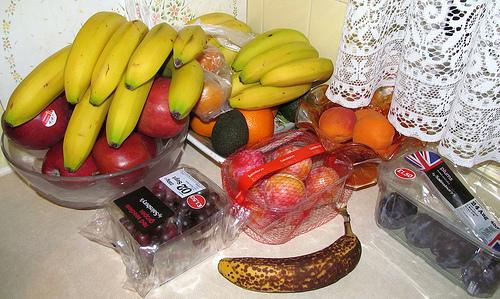Describe the image as if guiding a person with visual impairment. The image features a banana with brown spots on a counter, a bowl with red apples, a white curtain above, an avocado near oranges, and various fruits in different containers. Explain the scene in the image by highlighting the colors and shapes of the main elements. The scene displays a yellow, brown-spotted banana on a counter, a round bowl of red apples, a green avocado next to orange oranges, and various fruits in distinct packaging. Describe the composition of the image by mentioning the main objects and their placement. In the image, there is a spotted banana on a counter, a bowl of red apples nearby, while green avocado, oranges, and other fruits are scattered across the scene, with a white lace curtain in the background. Summarize the image by listing the most prominent items and their features. Banana with brown spots on a counter, bowl of red apples, green avocado, oranges, various fruit packaging, and white lace curtain. Write a description of the image emphasizing the textures and patterns present. A brown spotted yellow banana sits on a smooth countertop, surrounded by a shiny bowl of red apples, a green avocado, and various fruits with different packaging materials and labels. Describe the visual elements and their relationships in the image. A spotted banana rests on a counter in the foreground, while a bowl of red apples sits nearby, a green avocado is positioned next to oranges, and various fruits and packages fill the rest of the image. Provide a brief description of the most eye-catching elements in the image. A yellow banana with brown spots on a counter, a bowl filled with red apples, and an avocado in front of oranges catch the eye in this image. Write a concise summary of the key elements in the image. Spotted banana on counter, red apples in bowl, avocado near oranges, fruits in containers, and white lace curtain. Create a vivid description of the image focusing on the main subjects and their surroundings. A ripe banana with brown spots lies on a countertop amidst a colorful display of assorted fruits, including a bowl of red apples, an avocado near oranges, and a white lace curtain above. Mention the prominent features of the image and their characteristics. A brown spotted yellow banana is on a counter, there are red apples in a bowl, and a white lace curtain hangs over the scene with an avocado next to some oranges. 